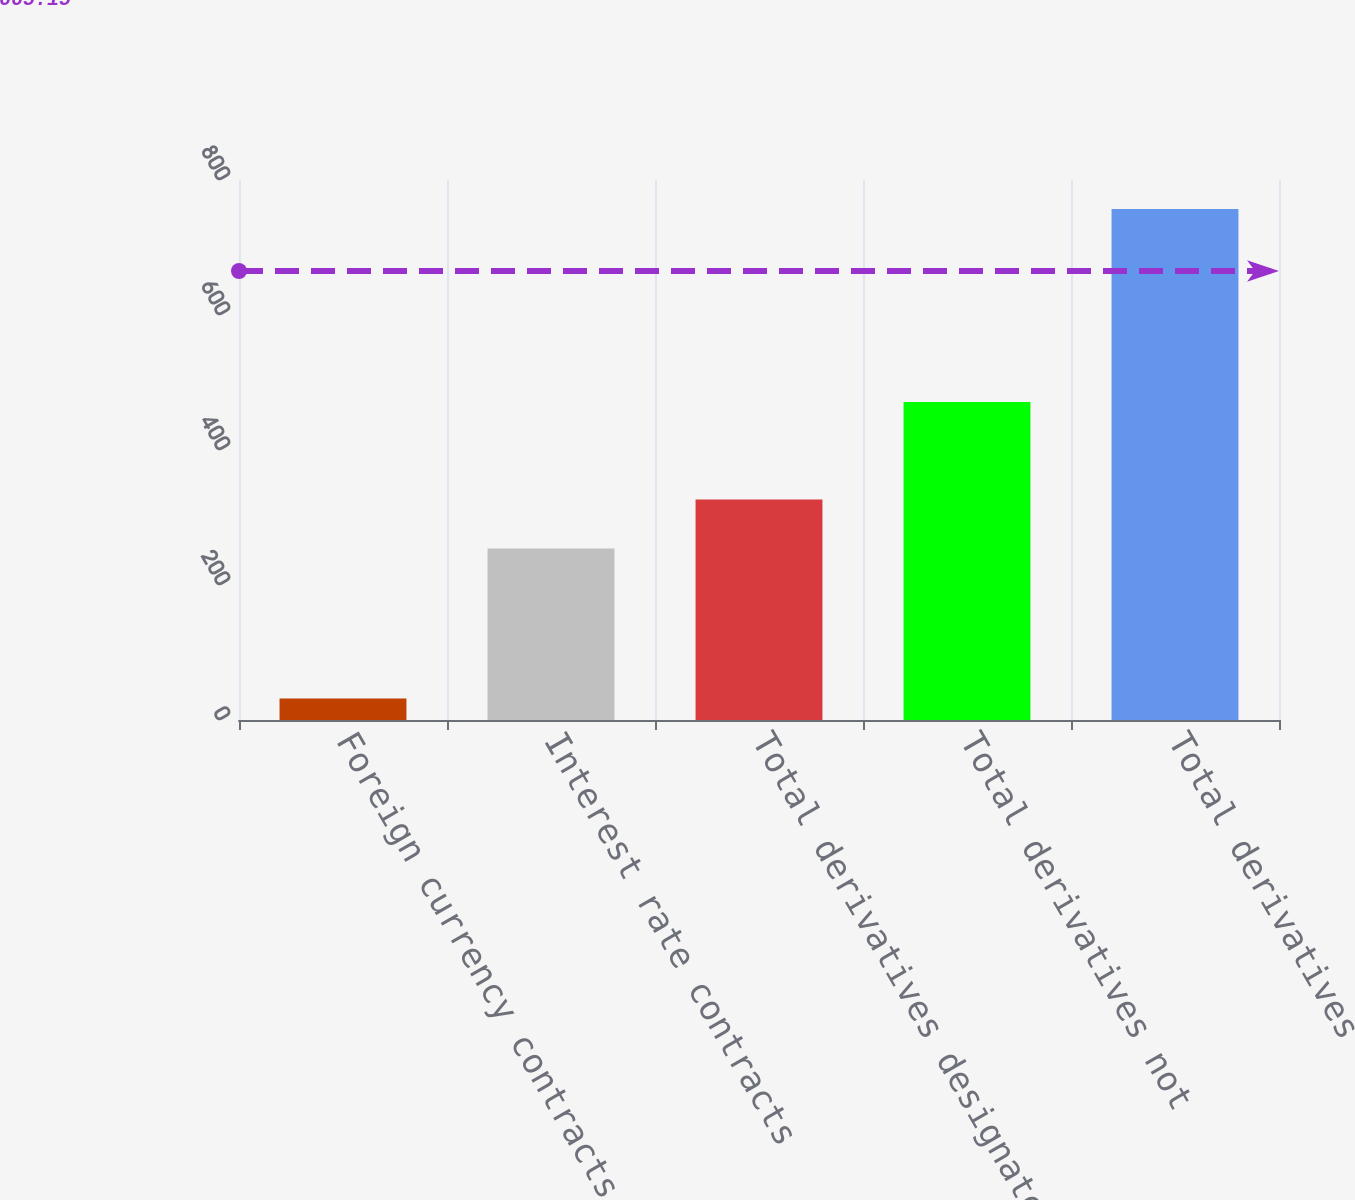Convert chart. <chart><loc_0><loc_0><loc_500><loc_500><bar_chart><fcel>Foreign currency contracts 3<fcel>Interest rate contracts<fcel>Total derivatives designated<fcel>Total derivatives not<fcel>Total derivatives<nl><fcel>32<fcel>254<fcel>326.5<fcel>471<fcel>757<nl></chart> 